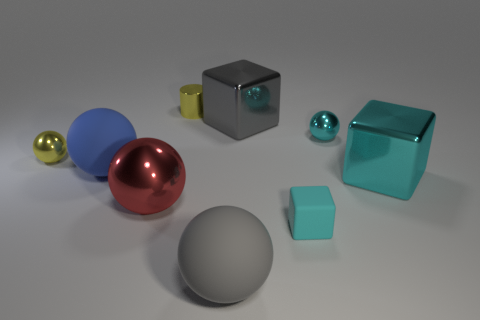Subtract all cyan balls. How many balls are left? 4 Subtract all gray spheres. How many cyan blocks are left? 2 Subtract all gray balls. How many balls are left? 4 Add 1 brown cylinders. How many objects exist? 10 Subtract 1 blocks. How many blocks are left? 2 Subtract all balls. How many objects are left? 4 Add 4 small cyan blocks. How many small cyan blocks are left? 5 Add 3 tiny cyan rubber objects. How many tiny cyan rubber objects exist? 4 Subtract 1 blue spheres. How many objects are left? 8 Subtract all brown cubes. Subtract all purple balls. How many cubes are left? 3 